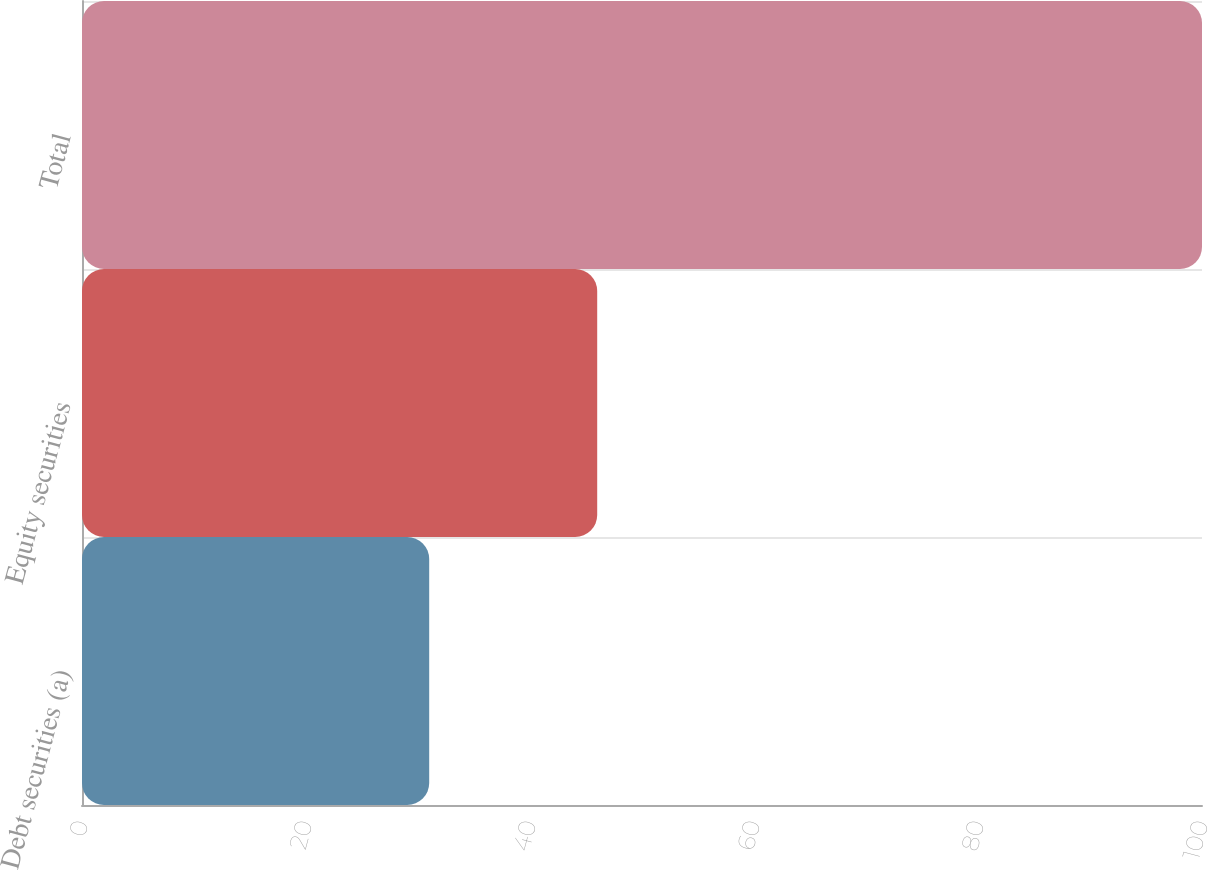Convert chart. <chart><loc_0><loc_0><loc_500><loc_500><bar_chart><fcel>Debt securities (a)<fcel>Equity securities<fcel>Total<nl><fcel>31<fcel>46<fcel>100<nl></chart> 